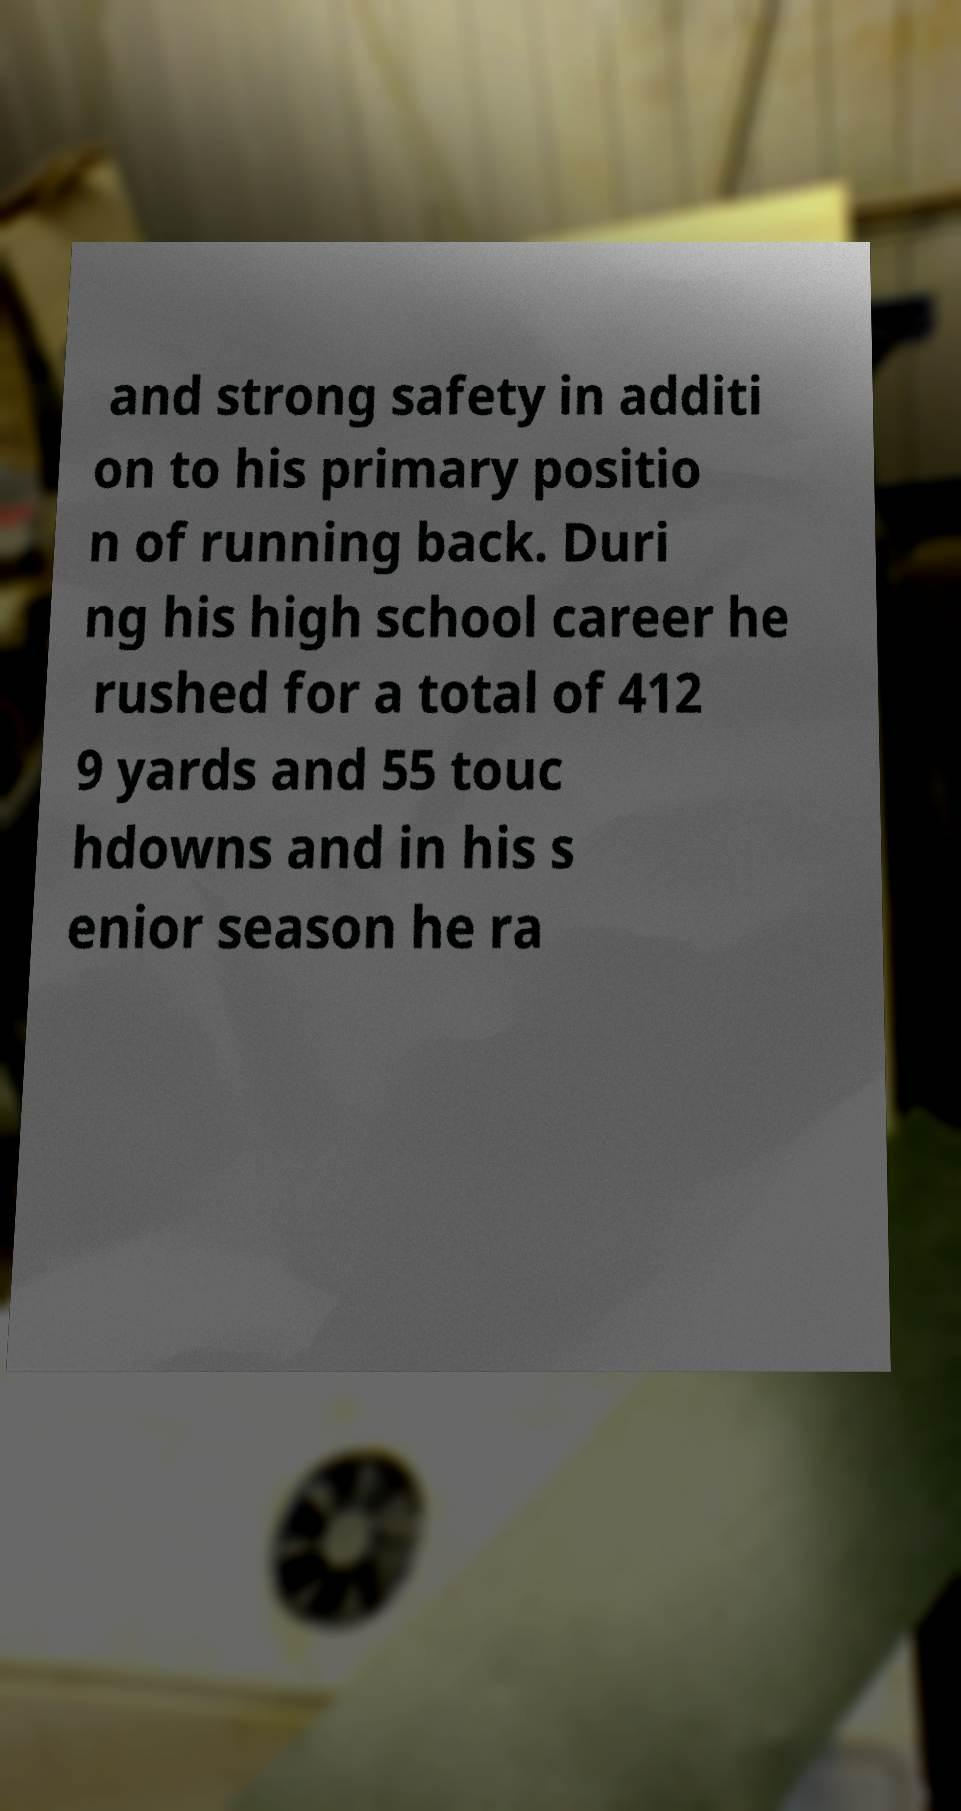Please read and relay the text visible in this image. What does it say? and strong safety in additi on to his primary positio n of running back. Duri ng his high school career he rushed for a total of 412 9 yards and 55 touc hdowns and in his s enior season he ra 